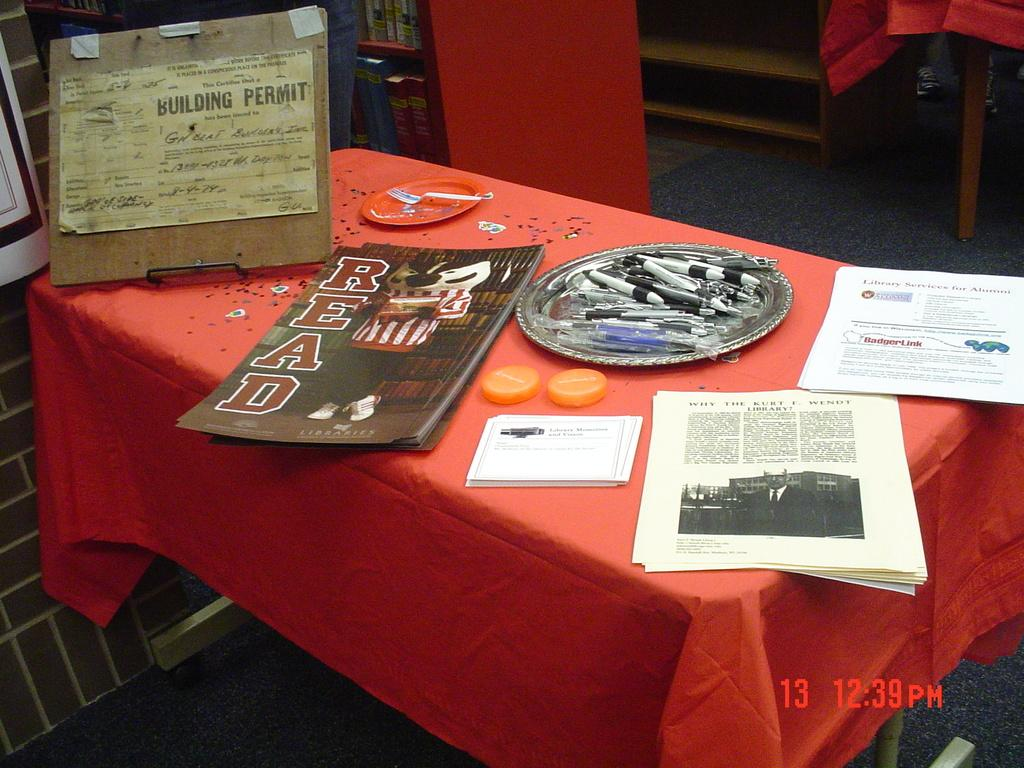<image>
Present a compact description of the photo's key features. Posters advertising libraries are among the many items on this table. 